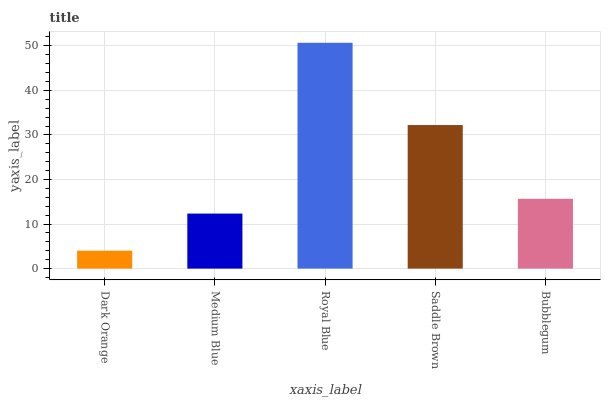Is Dark Orange the minimum?
Answer yes or no. Yes. Is Royal Blue the maximum?
Answer yes or no. Yes. Is Medium Blue the minimum?
Answer yes or no. No. Is Medium Blue the maximum?
Answer yes or no. No. Is Medium Blue greater than Dark Orange?
Answer yes or no. Yes. Is Dark Orange less than Medium Blue?
Answer yes or no. Yes. Is Dark Orange greater than Medium Blue?
Answer yes or no. No. Is Medium Blue less than Dark Orange?
Answer yes or no. No. Is Bubblegum the high median?
Answer yes or no. Yes. Is Bubblegum the low median?
Answer yes or no. Yes. Is Dark Orange the high median?
Answer yes or no. No. Is Saddle Brown the low median?
Answer yes or no. No. 